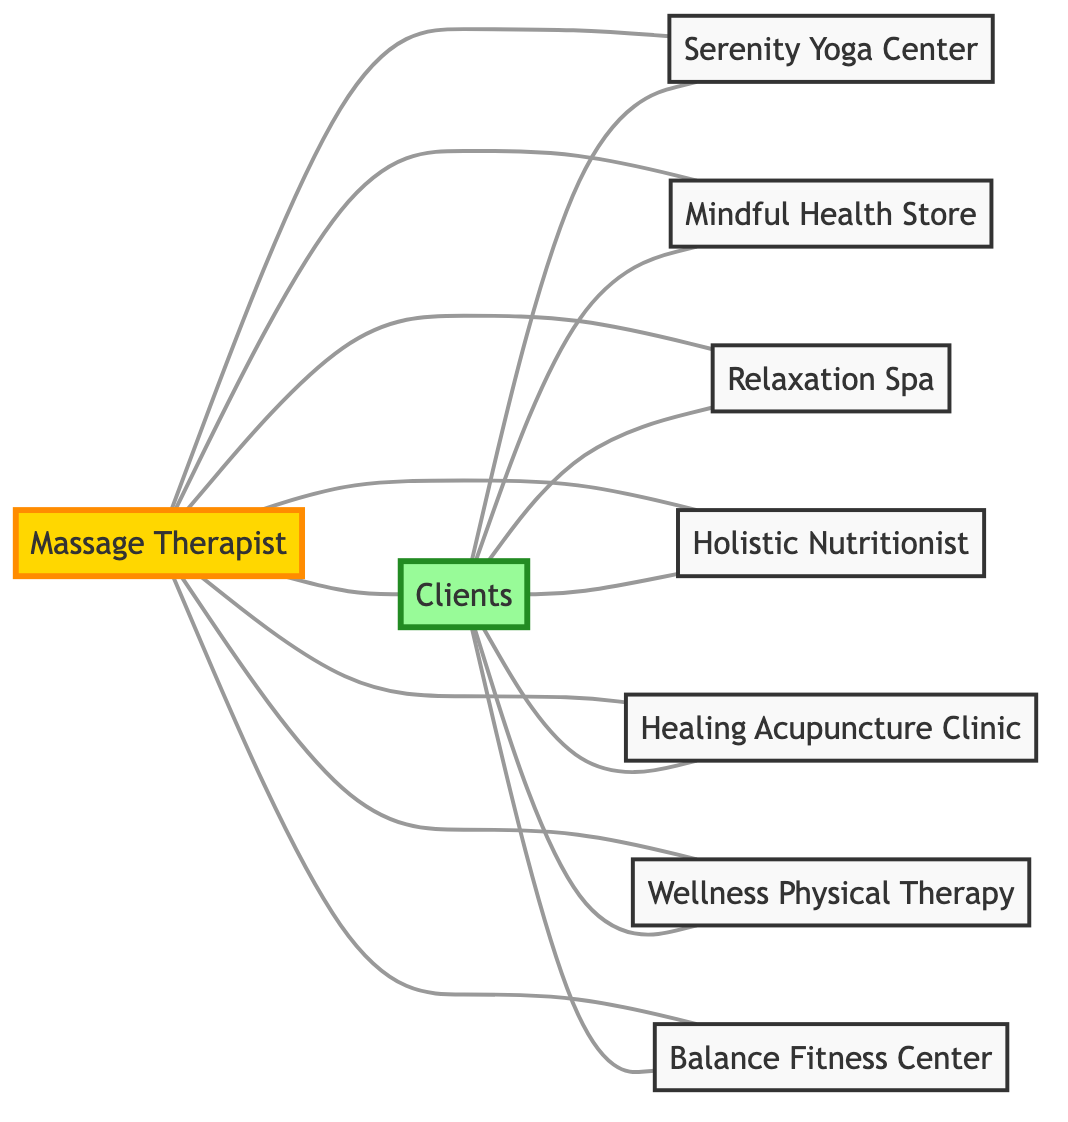What is the total number of nodes in the diagram? The diagram lists multiple entities, including the Massage Therapist, Clients, and various centers or stores. By counting each unique node, there are a total of 9 nodes represented.
Answer: 9 Which service is directly connected to Clients and offers relaxation therapies? The diagram shows that "Spa" is one of the services directly connected to "Clients". It is a relaxation-focused service, which can be identified based on the edge connecting them.
Answer: Relaxation Spa How many connections (edges) does the Massage Therapist have? To find the number of edges connected to the "Massage Therapist" node, we count the edges branching off from it. Upon reviewing, there are 8 direct connections from the therapist to other nodes.
Answer: 8 Is there a direct connection between the clients and the Holistic Nutritionist? Checking the edges connecting "Clients" and "Holistic Nutritionist", we can see that there is indeed a direct connection linking these two nodes.
Answer: Yes Which node is connected to both the Therapist and the Clients? Looking at the edges, "Yoga Center" is connected to both the Therapist and the Clients, as there are edges linking each of these nodes to it.
Answer: Serenity Yoga Center How many total edges link all nodes in the network? By adding up the connections shared between the nodes, we find the total number of edges in the diagram. There are 14 distinct edges in total linking the nodes within this network.
Answer: 14 Which professional is only connected to Clients and not the Therapist? In the diagram, the "Clients" node connects to various services but does not directly link back to the "Massage Therapist" node for "Healing Acupuncture Clinic". This professional solely relies on clients for connections.
Answer: Healing Acupuncture Clinic What type of centers are connected to both the Therapist and the clients? Analyzing the network, "Health Store," "Spa," and "Yoga Center" are all connected to both the Therapist and the Clients, showing that they provide services relevant to relaxation and wellness.
Answer: Spa, Health Store, Serenity Yoga Center 